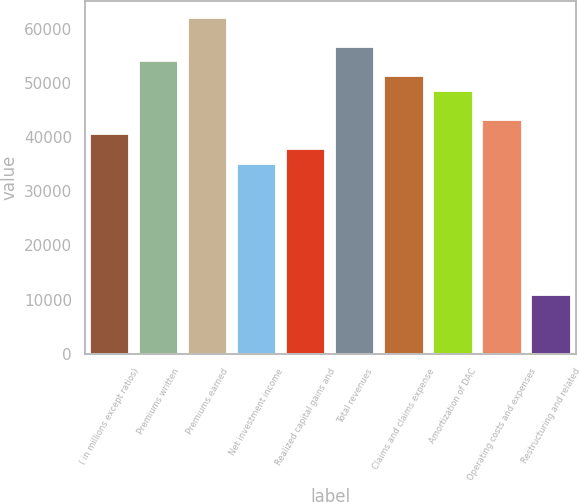Convert chart. <chart><loc_0><loc_0><loc_500><loc_500><bar_chart><fcel>( in millions except ratios)<fcel>Premiums written<fcel>Premiums earned<fcel>Net investment income<fcel>Realized capital gains and<fcel>Total revenues<fcel>Claims and claims expense<fcel>Amortization of DAC<fcel>Operating costs and expenses<fcel>Restructuring and related<nl><fcel>40450.4<fcel>53933.9<fcel>62024<fcel>35057.1<fcel>37753.8<fcel>56630.6<fcel>51237.2<fcel>48540.5<fcel>43147.1<fcel>10786.9<nl></chart> 